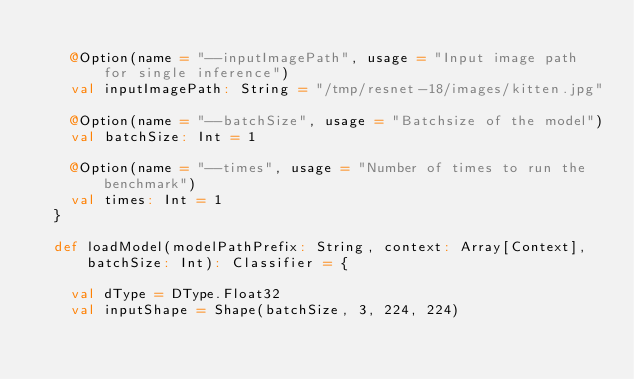Convert code to text. <code><loc_0><loc_0><loc_500><loc_500><_Scala_>
    @Option(name = "--inputImagePath", usage = "Input image path for single inference")
    val inputImagePath: String = "/tmp/resnet-18/images/kitten.jpg"

    @Option(name = "--batchSize", usage = "Batchsize of the model")
    val batchSize: Int = 1

    @Option(name = "--times", usage = "Number of times to run the benchmark")
    val times: Int = 1
  }

  def loadModel(modelPathPrefix: String, context: Array[Context], batchSize: Int): Classifier = {

    val dType = DType.Float32
    val inputShape = Shape(batchSize, 3, 224, 224)
</code> 